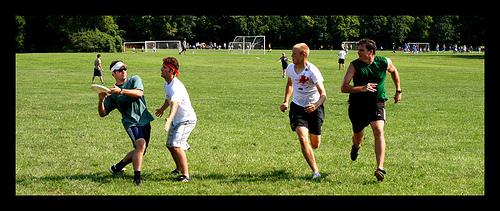Question: why are the men running?
Choices:
A. Race.
B. Exercise.
C. Being chased.
D. They are trying to catch the frisbee.
Answer with the letter. Answer: D Question: what are in the distance?
Choices:
A. Flames.
B. Soccer fields.
C. Police cars.
D. Storm clouds.
Answer with the letter. Answer: B 